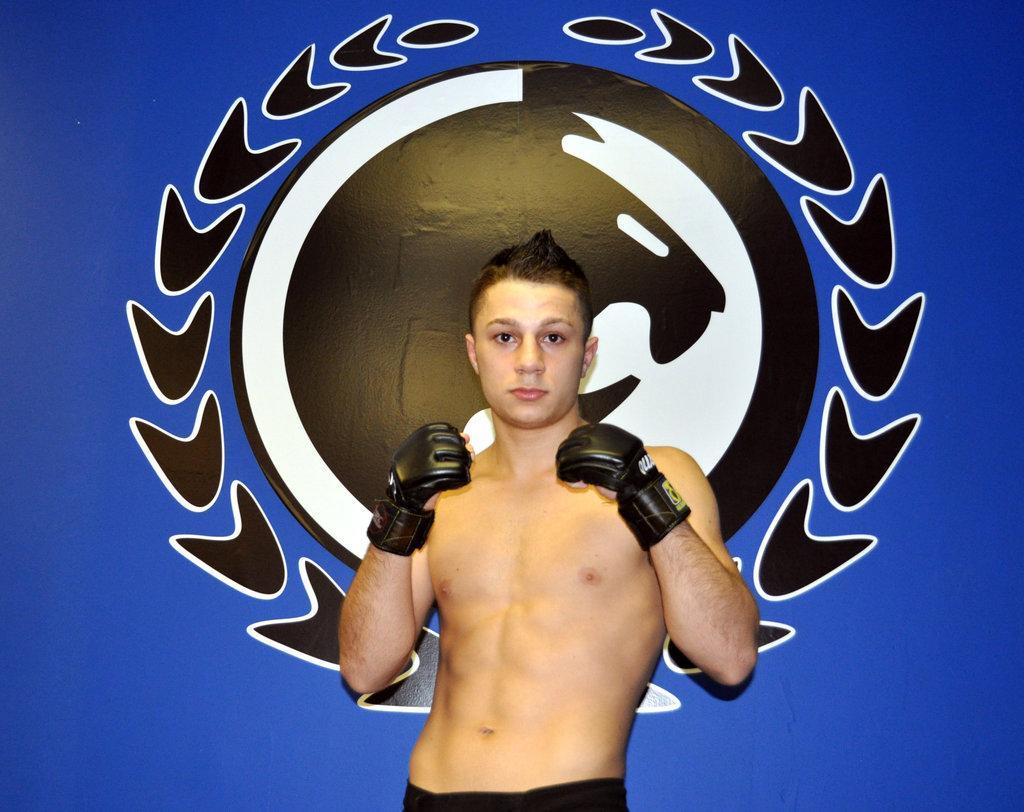Please provide a concise description of this image. In this image, we can see a person standing. We can also see the blue colored background with an image printed. 